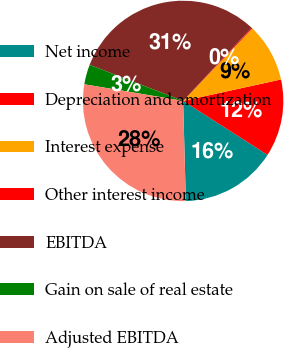Convert chart. <chart><loc_0><loc_0><loc_500><loc_500><pie_chart><fcel>Net income<fcel>Depreciation and amortization<fcel>Interest expense<fcel>Other interest income<fcel>EBITDA<fcel>Gain on sale of real estate<fcel>Adjusted EBITDA<nl><fcel>15.52%<fcel>12.48%<fcel>9.43%<fcel>0.16%<fcel>31.12%<fcel>3.2%<fcel>28.08%<nl></chart> 